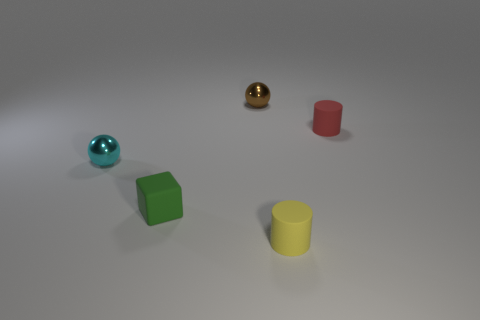Add 3 metallic balls. How many objects exist? 8 Subtract all cylinders. How many objects are left? 3 Add 5 brown objects. How many brown objects exist? 6 Subtract 0 red blocks. How many objects are left? 5 Subtract all big things. Subtract all small red matte things. How many objects are left? 4 Add 4 yellow matte cylinders. How many yellow matte cylinders are left? 5 